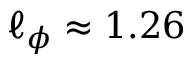Convert formula to latex. <formula><loc_0><loc_0><loc_500><loc_500>\ell _ { \phi } \approx 1 . 2 6</formula> 